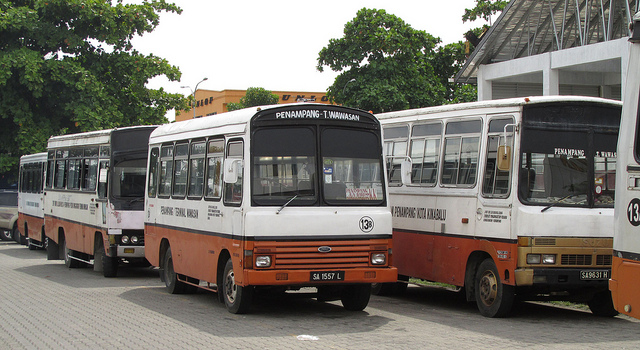Please transcribe the text information in this image. PENAMPANG T 13 51 1557 L 4 SA9631 13 